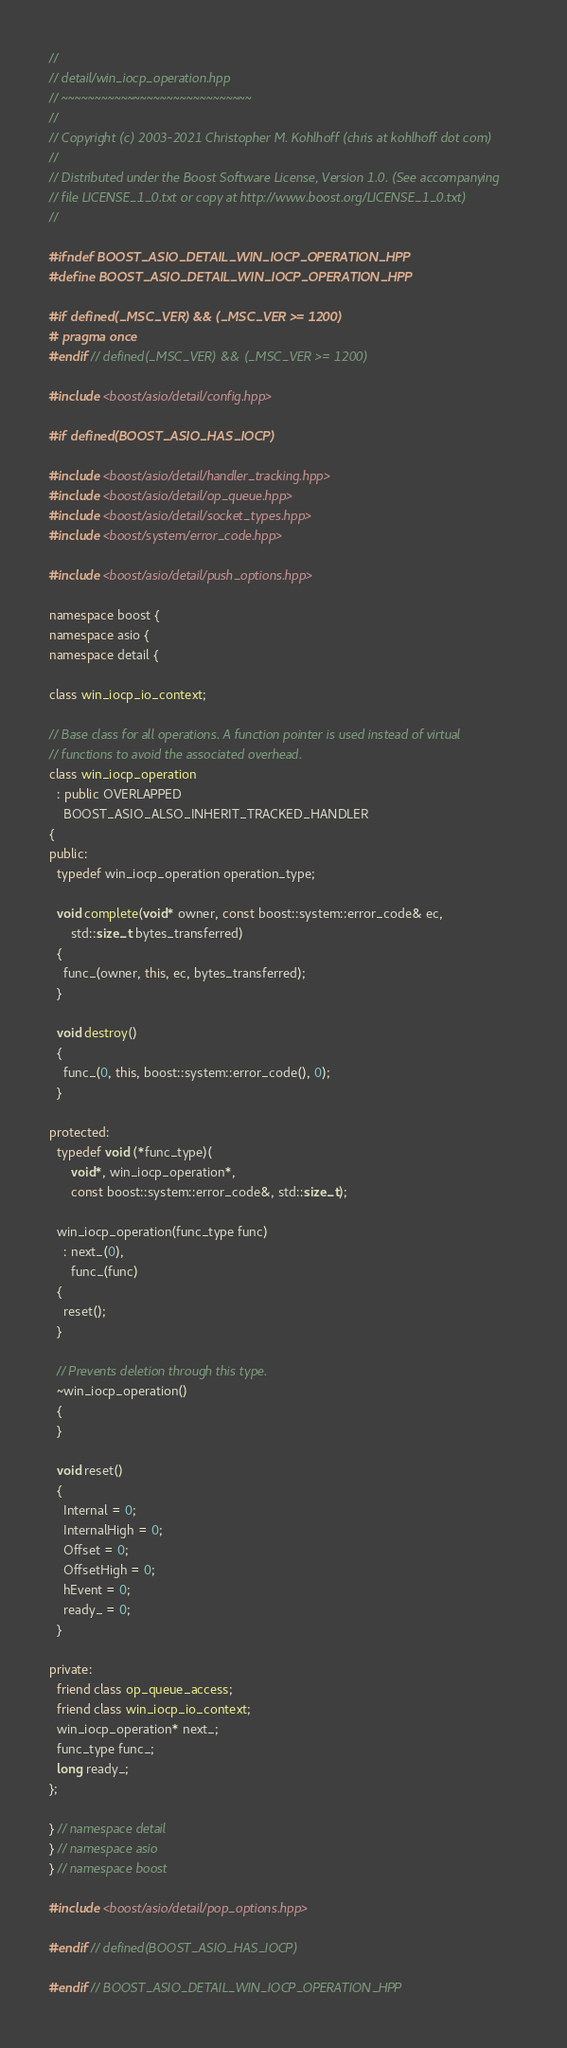Convert code to text. <code><loc_0><loc_0><loc_500><loc_500><_C++_>//
// detail/win_iocp_operation.hpp
// ~~~~~~~~~~~~~~~~~~~~~~~~~~~~~
//
// Copyright (c) 2003-2021 Christopher M. Kohlhoff (chris at kohlhoff dot com)
//
// Distributed under the Boost Software License, Version 1.0. (See accompanying
// file LICENSE_1_0.txt or copy at http://www.boost.org/LICENSE_1_0.txt)
//

#ifndef BOOST_ASIO_DETAIL_WIN_IOCP_OPERATION_HPP
#define BOOST_ASIO_DETAIL_WIN_IOCP_OPERATION_HPP

#if defined(_MSC_VER) && (_MSC_VER >= 1200)
# pragma once
#endif // defined(_MSC_VER) && (_MSC_VER >= 1200)

#include <boost/asio/detail/config.hpp>

#if defined(BOOST_ASIO_HAS_IOCP)

#include <boost/asio/detail/handler_tracking.hpp>
#include <boost/asio/detail/op_queue.hpp>
#include <boost/asio/detail/socket_types.hpp>
#include <boost/system/error_code.hpp>

#include <boost/asio/detail/push_options.hpp>

namespace boost {
namespace asio {
namespace detail {

class win_iocp_io_context;

// Base class for all operations. A function pointer is used instead of virtual
// functions to avoid the associated overhead.
class win_iocp_operation
  : public OVERLAPPED
    BOOST_ASIO_ALSO_INHERIT_TRACKED_HANDLER
{
public:
  typedef win_iocp_operation operation_type;

  void complete(void* owner, const boost::system::error_code& ec,
      std::size_t bytes_transferred)
  {
    func_(owner, this, ec, bytes_transferred);
  }

  void destroy()
  {
    func_(0, this, boost::system::error_code(), 0);
  }

protected:
  typedef void (*func_type)(
      void*, win_iocp_operation*,
      const boost::system::error_code&, std::size_t);

  win_iocp_operation(func_type func)
    : next_(0),
      func_(func)
  {
    reset();
  }

  // Prevents deletion through this type.
  ~win_iocp_operation()
  {
  }

  void reset()
  {
    Internal = 0;
    InternalHigh = 0;
    Offset = 0;
    OffsetHigh = 0;
    hEvent = 0;
    ready_ = 0;
  }

private:
  friend class op_queue_access;
  friend class win_iocp_io_context;
  win_iocp_operation* next_;
  func_type func_;
  long ready_;
};

} // namespace detail
} // namespace asio
} // namespace boost

#include <boost/asio/detail/pop_options.hpp>

#endif // defined(BOOST_ASIO_HAS_IOCP)

#endif // BOOST_ASIO_DETAIL_WIN_IOCP_OPERATION_HPP
</code> 